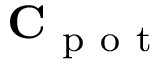<formula> <loc_0><loc_0><loc_500><loc_500>C _ { p o t }</formula> 